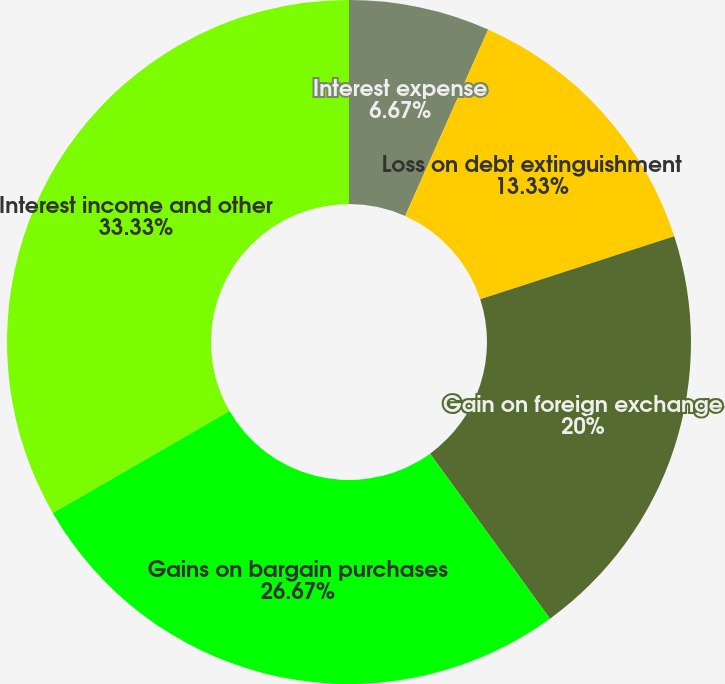<chart> <loc_0><loc_0><loc_500><loc_500><pie_chart><fcel>Interest expense<fcel>Loss on debt extinguishment<fcel>Gain on foreign exchange<fcel>Gains on bargain purchases<fcel>Interest income and other<nl><fcel>6.67%<fcel>13.33%<fcel>20.0%<fcel>26.67%<fcel>33.33%<nl></chart> 